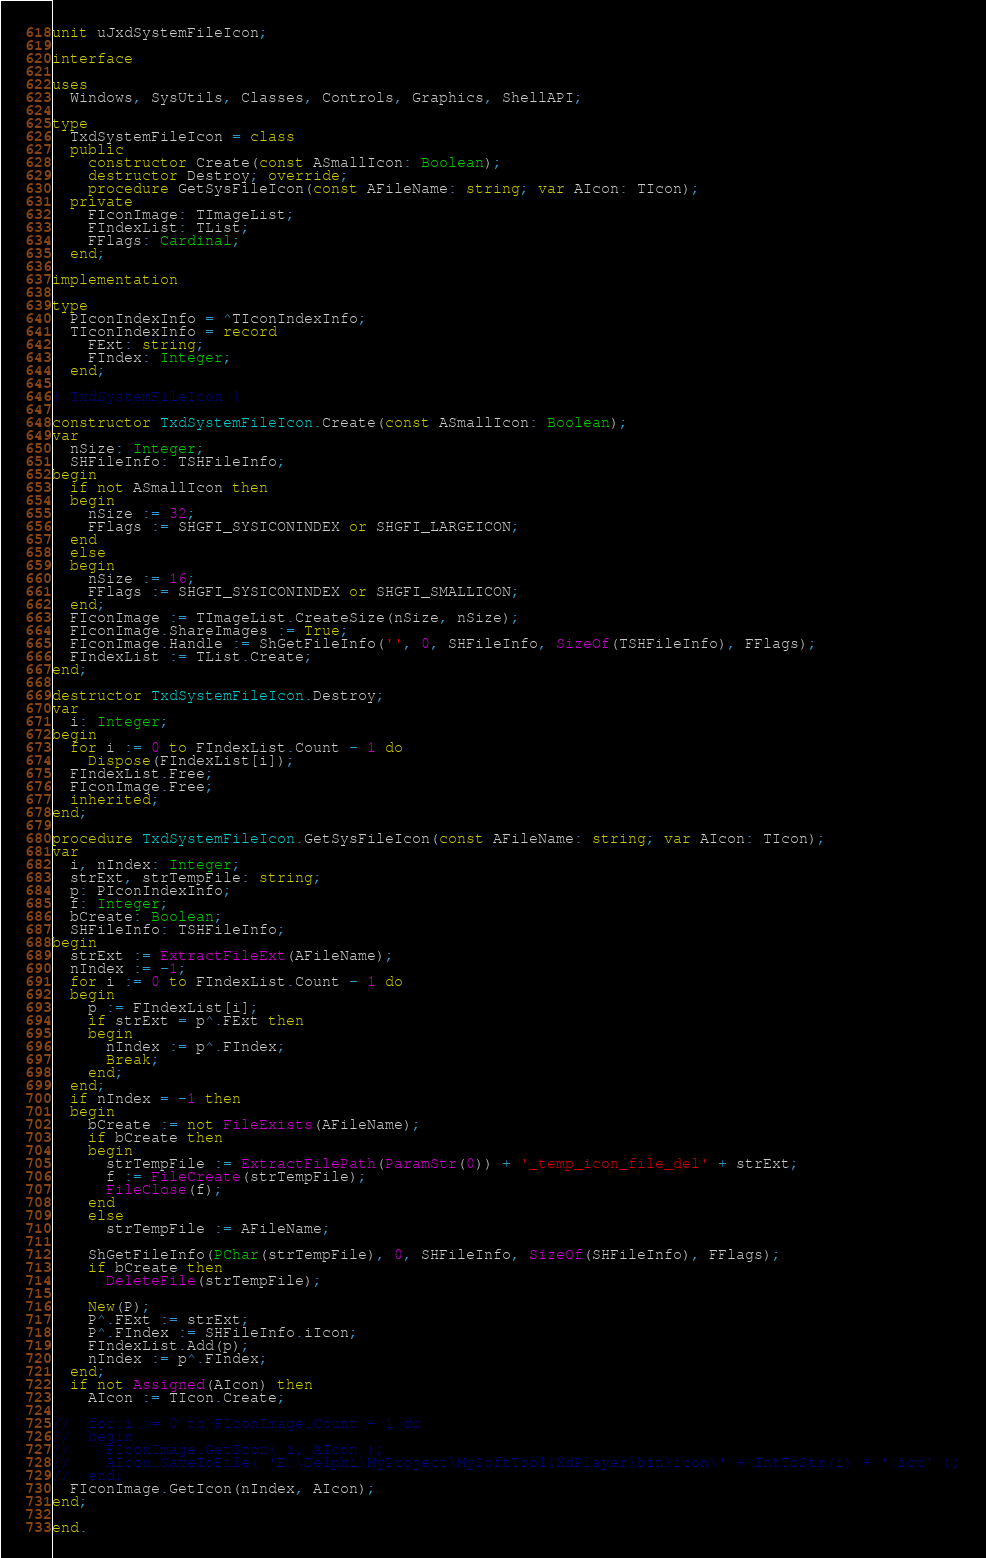Convert code to text. <code><loc_0><loc_0><loc_500><loc_500><_Pascal_>unit uJxdSystemFileIcon;

interface

uses
  Windows, SysUtils, Classes, Controls, Graphics, ShellAPI;

type
  TxdSystemFileIcon = class
  public
    constructor Create(const ASmallIcon: Boolean);
    destructor Destroy; override;
    procedure GetSysFileIcon(const AFileName: string; var AIcon: TIcon);
  private
    FIconImage: TImageList;
    FIndexList: TList;
    FFlags: Cardinal;
  end;

implementation

type
  PIconIndexInfo = ^TIconIndexInfo;
  TIconIndexInfo = record
    FExt: string;
    FIndex: Integer;
  end;

{ TxdSystemFileIcon }

constructor TxdSystemFileIcon.Create(const ASmallIcon: Boolean);
var
  nSize: Integer;
  SHFileInfo: TSHFileInfo;
begin
  if not ASmallIcon then
  begin
    nSize := 32;
    FFlags := SHGFI_SYSICONINDEX or SHGFI_LARGEICON;
  end
  else
  begin
    nSize := 16;
    FFlags := SHGFI_SYSICONINDEX or SHGFI_SMALLICON;
  end;
  FIconImage := TImageList.CreateSize(nSize, nSize);
  FIconImage.ShareImages := True;
  FIconImage.Handle := ShGetFileInfo('', 0, SHFileInfo, SizeOf(TSHFileInfo), FFlags);
  FIndexList := TList.Create;
end;

destructor TxdSystemFileIcon.Destroy;
var
  i: Integer;
begin
  for i := 0 to FIndexList.Count - 1 do
    Dispose(FIndexList[i]);
  FIndexList.Free;
  FIconImage.Free;
  inherited;
end;

procedure TxdSystemFileIcon.GetSysFileIcon(const AFileName: string; var AIcon: TIcon);
var
  i, nIndex: Integer;
  strExt, strTempFile: string;
  p: PIconIndexInfo;
  f: Integer;
  bCreate: Boolean;
  SHFileInfo: TSHFileInfo;
begin
  strExt := ExtractFileExt(AFileName);
  nIndex := -1;
  for i := 0 to FIndexList.Count - 1 do
  begin
    p := FIndexList[i];
    if strExt = p^.FExt then
    begin
      nIndex := p^.FIndex;
      Break;
    end;
  end;
  if nIndex = -1 then
  begin
    bCreate := not FileExists(AFileName);
    if bCreate then
    begin
      strTempFile := ExtractFilePath(ParamStr(0)) + '_temp_icon_file_del' + strExt;
      f := FileCreate(strTempFile);
      FileClose(f);
    end
    else
      strTempFile := AFileName;

    ShGetFileInfo(PChar(strTempFile), 0, SHFileInfo, SizeOf(SHFileInfo), FFlags);
    if bCreate then
      DeleteFile(strTempFile);

    New(P);
    P^.FExt := strExt;
    P^.FIndex := SHFileInfo.iIcon;
    FIndexList.Add(p);
    nIndex := p^.FIndex;
  end;
  if not Assigned(AIcon) then
    AIcon := TIcon.Create;

//  for i := 0 to FIconImage.Count - 1 do
//  begin
//    FIconImage.GetIcon( i, AIcon );
//    AIcon.SaveToFile( 'E:\Delphi\MyProject\MySoftTool\XdPlayer\bin\icon\' + IntToStr(i) + '.ico' );
//  end;
  FIconImage.GetIcon(nIndex, AIcon);
end;

end.
</code> 